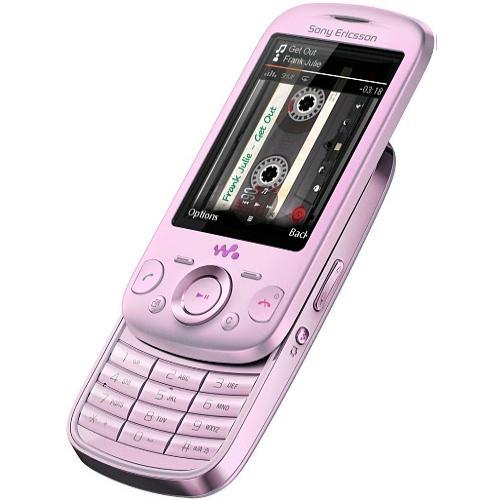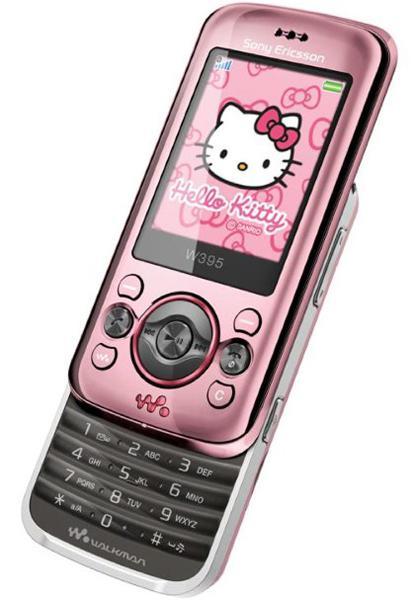The first image is the image on the left, the second image is the image on the right. For the images shown, is this caption "The screen of one of the phones is off." true? Answer yes or no. No. The first image is the image on the left, the second image is the image on the right. For the images displayed, is the sentence "Hello Kitty is on at least one of the phones." factually correct? Answer yes or no. Yes. 